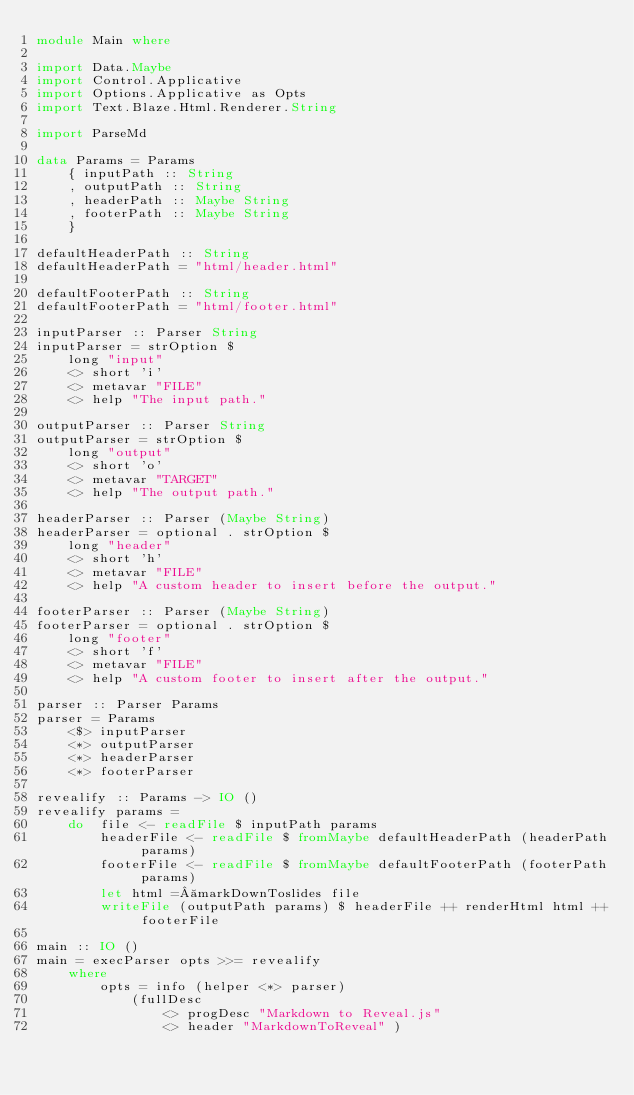<code> <loc_0><loc_0><loc_500><loc_500><_Haskell_>module Main where

import Data.Maybe
import Control.Applicative
import Options.Applicative as Opts
import Text.Blaze.Html.Renderer.String

import ParseMd

data Params = Params
	{ inputPath :: String
	, outputPath :: String
	, headerPath :: Maybe String
	, footerPath :: Maybe String
	}

defaultHeaderPath :: String
defaultHeaderPath = "html/header.html"

defaultFooterPath :: String
defaultFooterPath = "html/footer.html"

inputParser :: Parser String
inputParser = strOption $
	long "input"
	<> short 'i'
	<> metavar "FILE"
	<> help "The input path."

outputParser :: Parser String
outputParser = strOption $
	long "output"
	<> short 'o'
	<> metavar "TARGET"
	<> help "The output path."

headerParser :: Parser (Maybe String)
headerParser = optional . strOption $
	long "header"
	<> short 'h'
	<> metavar "FILE"
	<> help "A custom header to insert before the output."

footerParser :: Parser (Maybe String)
footerParser = optional . strOption $
	long "footer"
	<> short 'f'
	<> metavar "FILE"
	<> help "A custom footer to insert after the output."

parser :: Parser Params
parser = Params
	<$> inputParser
	<*> outputParser
	<*> headerParser
	<*> footerParser

revealify :: Params -> IO ()
revealify params =
	do	file <- readFile $ inputPath params
		headerFile <- readFile $ fromMaybe defaultHeaderPath (headerPath params)
		footerFile <- readFile $ fromMaybe defaultFooterPath (footerPath params)
		let html = markDownToslides file
		writeFile (outputPath params) $ headerFile ++ renderHtml html ++ footerFile

main :: IO ()
main = execParser opts >>= revealify
	where
		opts = info (helper <*> parser)
			(fullDesc
				<> progDesc "Markdown to Reveal.js"
				<> header "MarkdownToReveal" )
</code> 